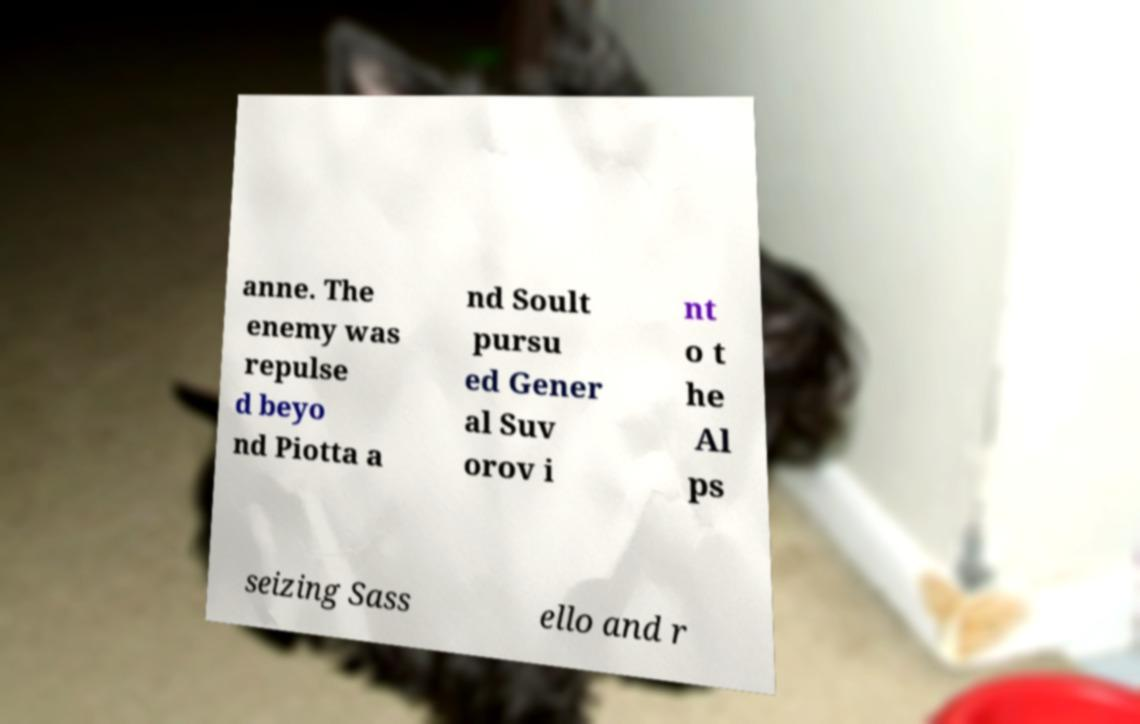For documentation purposes, I need the text within this image transcribed. Could you provide that? anne. The enemy was repulse d beyo nd Piotta a nd Soult pursu ed Gener al Suv orov i nt o t he Al ps seizing Sass ello and r 